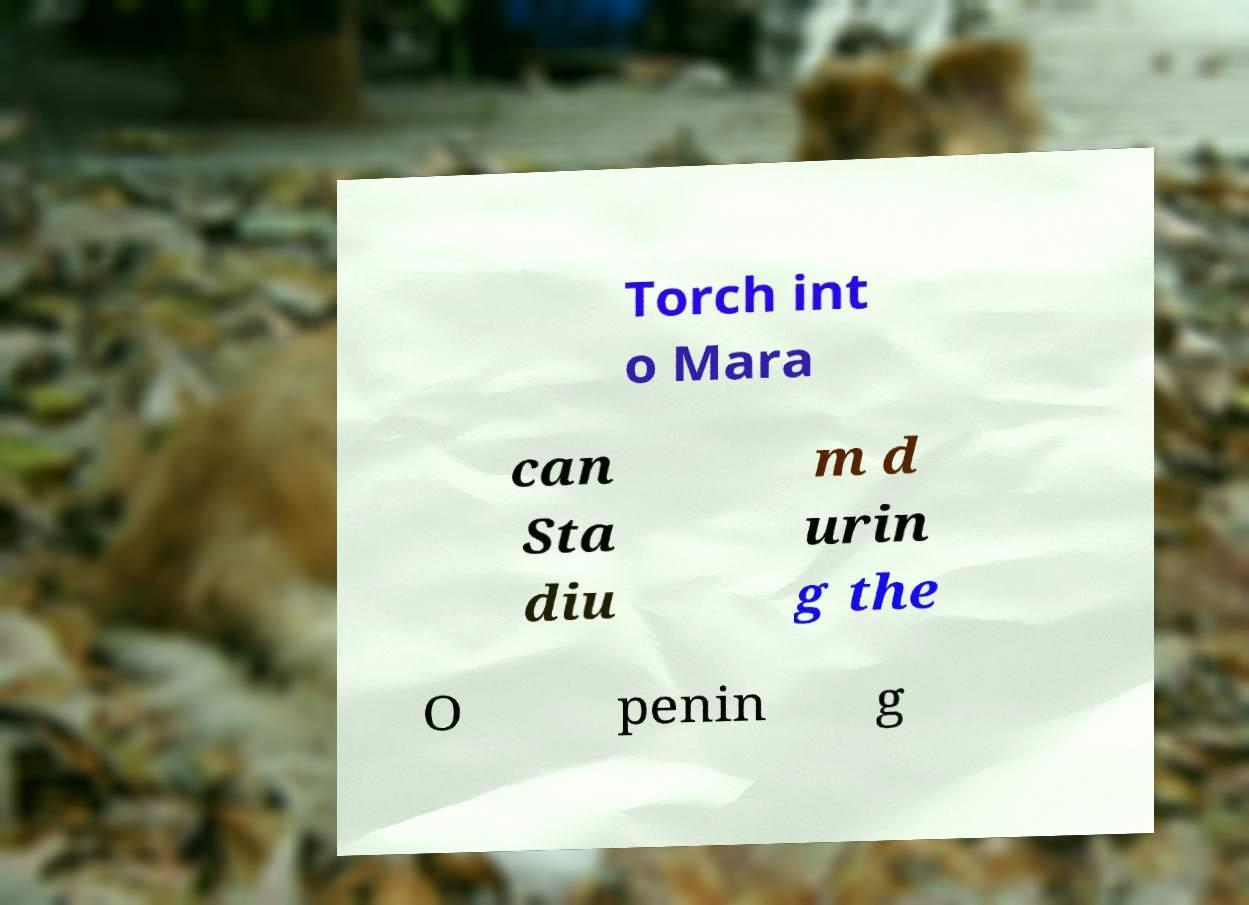For documentation purposes, I need the text within this image transcribed. Could you provide that? Torch int o Mara can Sta diu m d urin g the O penin g 